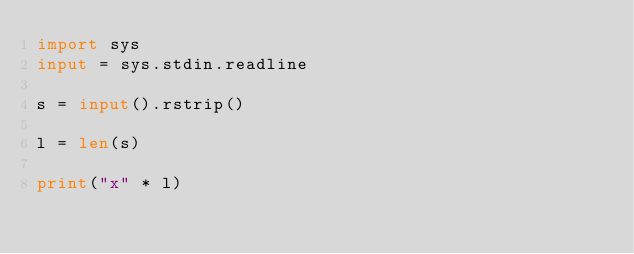<code> <loc_0><loc_0><loc_500><loc_500><_Python_>import sys
input = sys.stdin.readline

s = input().rstrip()

l = len(s)

print("x" * l)</code> 